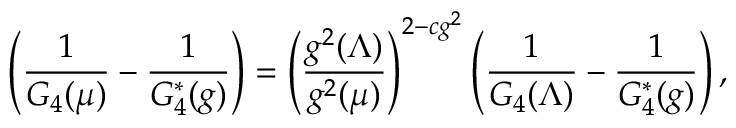Convert formula to latex. <formula><loc_0><loc_0><loc_500><loc_500>\left ( \frac { 1 } { G _ { 4 } ( \mu ) } - \frac { 1 } { G _ { 4 } ^ { * } ( g ) } \right ) = \left ( \frac { g ^ { 2 } ( \Lambda ) } { g ^ { 2 } ( \mu ) } \right ) ^ { 2 - c g ^ { 2 } } \left ( \frac { 1 } { G _ { 4 } ( \Lambda ) } - \frac { 1 } { G _ { 4 } ^ { * } ( g ) } \right ) ,</formula> 